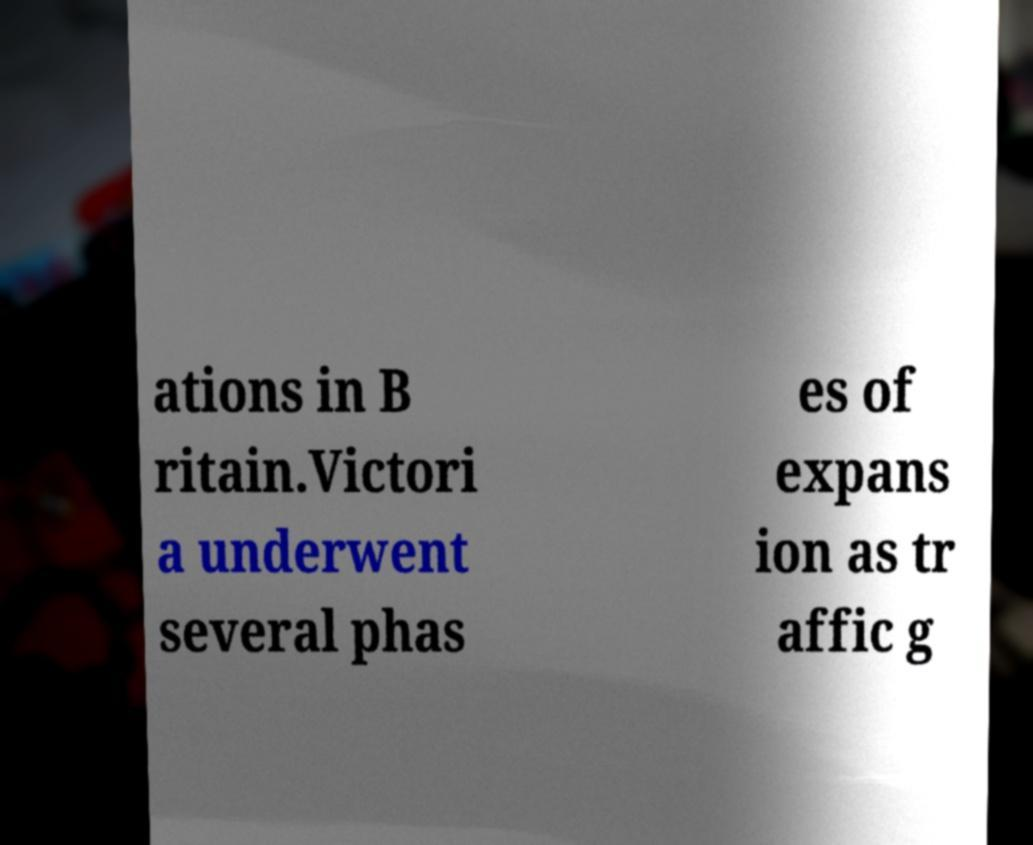I need the written content from this picture converted into text. Can you do that? ations in B ritain.Victori a underwent several phas es of expans ion as tr affic g 